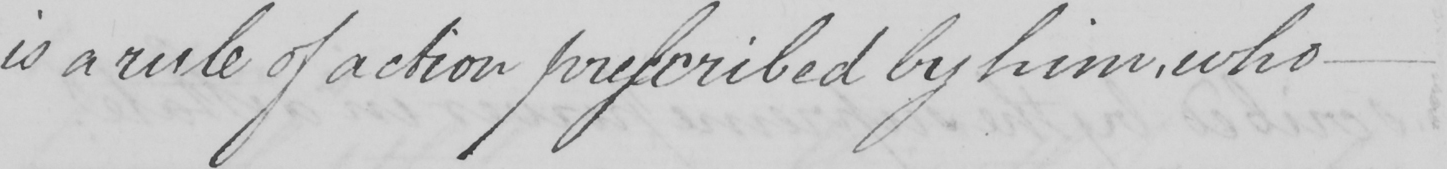What does this handwritten line say? is a rule of action prescribed by him, who 